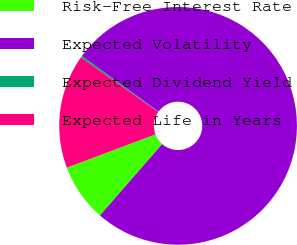Convert chart. <chart><loc_0><loc_0><loc_500><loc_500><pie_chart><fcel>Risk-Free Interest Rate<fcel>Expected Volatility<fcel>Expected Dividend Yield<fcel>Expected Life in Years<nl><fcel>7.86%<fcel>76.41%<fcel>0.25%<fcel>15.48%<nl></chart> 